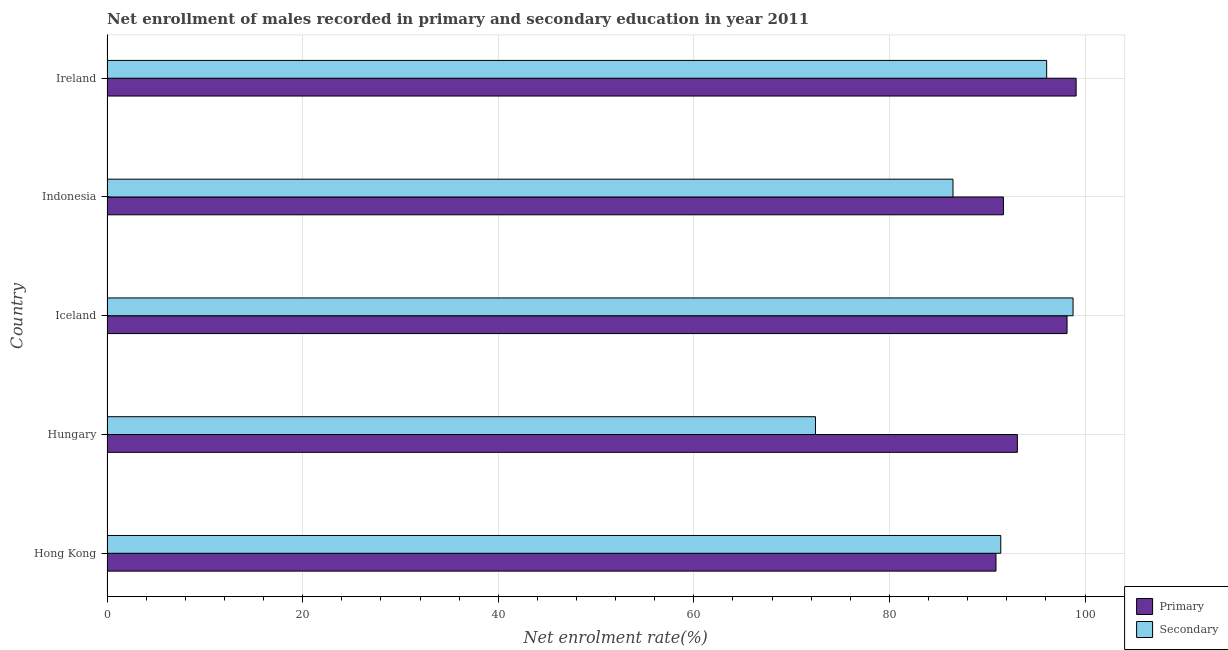How many different coloured bars are there?
Your answer should be very brief. 2. How many groups of bars are there?
Your answer should be very brief. 5. Are the number of bars on each tick of the Y-axis equal?
Your answer should be very brief. Yes. How many bars are there on the 3rd tick from the top?
Your response must be concise. 2. How many bars are there on the 5th tick from the bottom?
Offer a terse response. 2. What is the label of the 4th group of bars from the top?
Provide a short and direct response. Hungary. What is the enrollment rate in secondary education in Indonesia?
Your answer should be very brief. 86.49. Across all countries, what is the maximum enrollment rate in secondary education?
Give a very brief answer. 98.77. Across all countries, what is the minimum enrollment rate in primary education?
Your answer should be very brief. 90.89. In which country was the enrollment rate in primary education maximum?
Make the answer very short. Ireland. In which country was the enrollment rate in secondary education minimum?
Ensure brevity in your answer.  Hungary. What is the total enrollment rate in secondary education in the graph?
Give a very brief answer. 445.15. What is the difference between the enrollment rate in secondary education in Hungary and that in Iceland?
Make the answer very short. -26.34. What is the difference between the enrollment rate in primary education in Hong Kong and the enrollment rate in secondary education in Ireland?
Your answer should be compact. -5.18. What is the average enrollment rate in secondary education per country?
Your answer should be compact. 89.03. What is the difference between the enrollment rate in primary education and enrollment rate in secondary education in Iceland?
Offer a terse response. -0.61. In how many countries, is the enrollment rate in secondary education greater than 60 %?
Provide a succinct answer. 5. What is the ratio of the enrollment rate in primary education in Hungary to that in Ireland?
Offer a terse response. 0.94. Is the enrollment rate in secondary education in Hungary less than that in Ireland?
Provide a short and direct response. Yes. What is the difference between the highest and the second highest enrollment rate in primary education?
Give a very brief answer. 0.93. What is the difference between the highest and the lowest enrollment rate in secondary education?
Ensure brevity in your answer.  26.34. In how many countries, is the enrollment rate in secondary education greater than the average enrollment rate in secondary education taken over all countries?
Offer a terse response. 3. What does the 2nd bar from the top in Indonesia represents?
Offer a very short reply. Primary. What does the 2nd bar from the bottom in Ireland represents?
Your answer should be compact. Secondary. How many bars are there?
Make the answer very short. 10. Are all the bars in the graph horizontal?
Your answer should be very brief. Yes. Are the values on the major ticks of X-axis written in scientific E-notation?
Offer a very short reply. No. How many legend labels are there?
Your answer should be very brief. 2. How are the legend labels stacked?
Give a very brief answer. Vertical. What is the title of the graph?
Give a very brief answer. Net enrollment of males recorded in primary and secondary education in year 2011. What is the label or title of the X-axis?
Your answer should be very brief. Net enrolment rate(%). What is the Net enrolment rate(%) in Primary in Hong Kong?
Your response must be concise. 90.89. What is the Net enrolment rate(%) in Secondary in Hong Kong?
Provide a succinct answer. 91.38. What is the Net enrolment rate(%) of Primary in Hungary?
Your answer should be very brief. 93.08. What is the Net enrolment rate(%) in Secondary in Hungary?
Provide a short and direct response. 72.43. What is the Net enrolment rate(%) in Primary in Iceland?
Offer a terse response. 98.16. What is the Net enrolment rate(%) of Secondary in Iceland?
Your answer should be compact. 98.77. What is the Net enrolment rate(%) of Primary in Indonesia?
Your answer should be compact. 91.65. What is the Net enrolment rate(%) in Secondary in Indonesia?
Ensure brevity in your answer.  86.49. What is the Net enrolment rate(%) in Primary in Ireland?
Your answer should be compact. 99.08. What is the Net enrolment rate(%) in Secondary in Ireland?
Provide a short and direct response. 96.07. Across all countries, what is the maximum Net enrolment rate(%) of Primary?
Ensure brevity in your answer.  99.08. Across all countries, what is the maximum Net enrolment rate(%) of Secondary?
Keep it short and to the point. 98.77. Across all countries, what is the minimum Net enrolment rate(%) of Primary?
Give a very brief answer. 90.89. Across all countries, what is the minimum Net enrolment rate(%) in Secondary?
Give a very brief answer. 72.43. What is the total Net enrolment rate(%) in Primary in the graph?
Keep it short and to the point. 472.86. What is the total Net enrolment rate(%) of Secondary in the graph?
Give a very brief answer. 445.15. What is the difference between the Net enrolment rate(%) in Primary in Hong Kong and that in Hungary?
Your answer should be compact. -2.19. What is the difference between the Net enrolment rate(%) of Secondary in Hong Kong and that in Hungary?
Offer a terse response. 18.95. What is the difference between the Net enrolment rate(%) of Primary in Hong Kong and that in Iceland?
Offer a terse response. -7.26. What is the difference between the Net enrolment rate(%) in Secondary in Hong Kong and that in Iceland?
Provide a succinct answer. -7.39. What is the difference between the Net enrolment rate(%) of Primary in Hong Kong and that in Indonesia?
Your answer should be very brief. -0.76. What is the difference between the Net enrolment rate(%) in Secondary in Hong Kong and that in Indonesia?
Your response must be concise. 4.89. What is the difference between the Net enrolment rate(%) in Primary in Hong Kong and that in Ireland?
Give a very brief answer. -8.19. What is the difference between the Net enrolment rate(%) of Secondary in Hong Kong and that in Ireland?
Ensure brevity in your answer.  -4.69. What is the difference between the Net enrolment rate(%) of Primary in Hungary and that in Iceland?
Your answer should be very brief. -5.08. What is the difference between the Net enrolment rate(%) of Secondary in Hungary and that in Iceland?
Provide a succinct answer. -26.34. What is the difference between the Net enrolment rate(%) in Primary in Hungary and that in Indonesia?
Your answer should be compact. 1.42. What is the difference between the Net enrolment rate(%) in Secondary in Hungary and that in Indonesia?
Your response must be concise. -14.06. What is the difference between the Net enrolment rate(%) in Primary in Hungary and that in Ireland?
Offer a terse response. -6.01. What is the difference between the Net enrolment rate(%) of Secondary in Hungary and that in Ireland?
Ensure brevity in your answer.  -23.64. What is the difference between the Net enrolment rate(%) in Primary in Iceland and that in Indonesia?
Give a very brief answer. 6.5. What is the difference between the Net enrolment rate(%) of Secondary in Iceland and that in Indonesia?
Your answer should be very brief. 12.28. What is the difference between the Net enrolment rate(%) of Primary in Iceland and that in Ireland?
Your answer should be very brief. -0.93. What is the difference between the Net enrolment rate(%) of Primary in Indonesia and that in Ireland?
Ensure brevity in your answer.  -7.43. What is the difference between the Net enrolment rate(%) in Secondary in Indonesia and that in Ireland?
Ensure brevity in your answer.  -9.58. What is the difference between the Net enrolment rate(%) of Primary in Hong Kong and the Net enrolment rate(%) of Secondary in Hungary?
Your response must be concise. 18.46. What is the difference between the Net enrolment rate(%) in Primary in Hong Kong and the Net enrolment rate(%) in Secondary in Iceland?
Offer a very short reply. -7.88. What is the difference between the Net enrolment rate(%) in Primary in Hong Kong and the Net enrolment rate(%) in Secondary in Indonesia?
Give a very brief answer. 4.4. What is the difference between the Net enrolment rate(%) of Primary in Hong Kong and the Net enrolment rate(%) of Secondary in Ireland?
Offer a terse response. -5.18. What is the difference between the Net enrolment rate(%) of Primary in Hungary and the Net enrolment rate(%) of Secondary in Iceland?
Provide a succinct answer. -5.7. What is the difference between the Net enrolment rate(%) in Primary in Hungary and the Net enrolment rate(%) in Secondary in Indonesia?
Your response must be concise. 6.58. What is the difference between the Net enrolment rate(%) in Primary in Hungary and the Net enrolment rate(%) in Secondary in Ireland?
Your response must be concise. -3. What is the difference between the Net enrolment rate(%) of Primary in Iceland and the Net enrolment rate(%) of Secondary in Indonesia?
Offer a very short reply. 11.66. What is the difference between the Net enrolment rate(%) in Primary in Iceland and the Net enrolment rate(%) in Secondary in Ireland?
Ensure brevity in your answer.  2.08. What is the difference between the Net enrolment rate(%) of Primary in Indonesia and the Net enrolment rate(%) of Secondary in Ireland?
Make the answer very short. -4.42. What is the average Net enrolment rate(%) in Primary per country?
Give a very brief answer. 94.57. What is the average Net enrolment rate(%) in Secondary per country?
Provide a succinct answer. 89.03. What is the difference between the Net enrolment rate(%) in Primary and Net enrolment rate(%) in Secondary in Hong Kong?
Ensure brevity in your answer.  -0.49. What is the difference between the Net enrolment rate(%) in Primary and Net enrolment rate(%) in Secondary in Hungary?
Keep it short and to the point. 20.64. What is the difference between the Net enrolment rate(%) in Primary and Net enrolment rate(%) in Secondary in Iceland?
Give a very brief answer. -0.62. What is the difference between the Net enrolment rate(%) in Primary and Net enrolment rate(%) in Secondary in Indonesia?
Offer a very short reply. 5.16. What is the difference between the Net enrolment rate(%) in Primary and Net enrolment rate(%) in Secondary in Ireland?
Make the answer very short. 3.01. What is the ratio of the Net enrolment rate(%) of Primary in Hong Kong to that in Hungary?
Your response must be concise. 0.98. What is the ratio of the Net enrolment rate(%) in Secondary in Hong Kong to that in Hungary?
Your answer should be compact. 1.26. What is the ratio of the Net enrolment rate(%) of Primary in Hong Kong to that in Iceland?
Offer a very short reply. 0.93. What is the ratio of the Net enrolment rate(%) in Secondary in Hong Kong to that in Iceland?
Provide a succinct answer. 0.93. What is the ratio of the Net enrolment rate(%) of Secondary in Hong Kong to that in Indonesia?
Your response must be concise. 1.06. What is the ratio of the Net enrolment rate(%) in Primary in Hong Kong to that in Ireland?
Your answer should be very brief. 0.92. What is the ratio of the Net enrolment rate(%) in Secondary in Hong Kong to that in Ireland?
Provide a short and direct response. 0.95. What is the ratio of the Net enrolment rate(%) of Primary in Hungary to that in Iceland?
Make the answer very short. 0.95. What is the ratio of the Net enrolment rate(%) in Secondary in Hungary to that in Iceland?
Your response must be concise. 0.73. What is the ratio of the Net enrolment rate(%) in Primary in Hungary to that in Indonesia?
Keep it short and to the point. 1.02. What is the ratio of the Net enrolment rate(%) in Secondary in Hungary to that in Indonesia?
Keep it short and to the point. 0.84. What is the ratio of the Net enrolment rate(%) of Primary in Hungary to that in Ireland?
Keep it short and to the point. 0.94. What is the ratio of the Net enrolment rate(%) of Secondary in Hungary to that in Ireland?
Give a very brief answer. 0.75. What is the ratio of the Net enrolment rate(%) of Primary in Iceland to that in Indonesia?
Keep it short and to the point. 1.07. What is the ratio of the Net enrolment rate(%) in Secondary in Iceland to that in Indonesia?
Make the answer very short. 1.14. What is the ratio of the Net enrolment rate(%) in Primary in Iceland to that in Ireland?
Make the answer very short. 0.99. What is the ratio of the Net enrolment rate(%) of Secondary in Iceland to that in Ireland?
Provide a succinct answer. 1.03. What is the ratio of the Net enrolment rate(%) in Primary in Indonesia to that in Ireland?
Ensure brevity in your answer.  0.93. What is the ratio of the Net enrolment rate(%) of Secondary in Indonesia to that in Ireland?
Your response must be concise. 0.9. What is the difference between the highest and the second highest Net enrolment rate(%) in Primary?
Your response must be concise. 0.93. What is the difference between the highest and the second highest Net enrolment rate(%) of Secondary?
Your answer should be very brief. 2.7. What is the difference between the highest and the lowest Net enrolment rate(%) in Primary?
Make the answer very short. 8.19. What is the difference between the highest and the lowest Net enrolment rate(%) in Secondary?
Give a very brief answer. 26.34. 